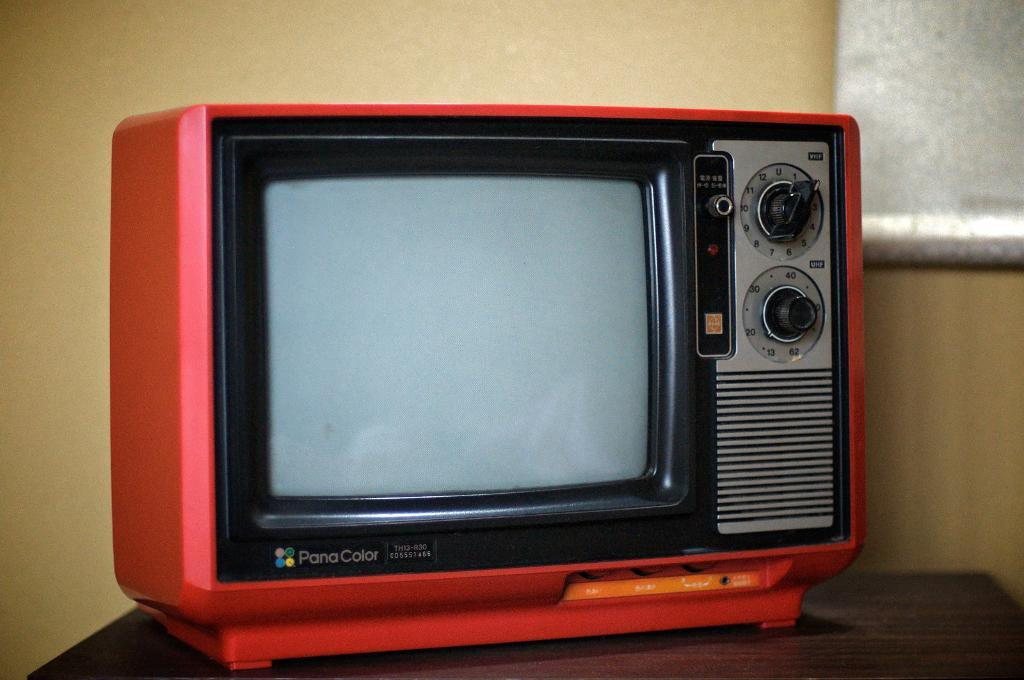Provide a one-sentence caption for the provided image. An old Pana Coice tv set sits on a table. 